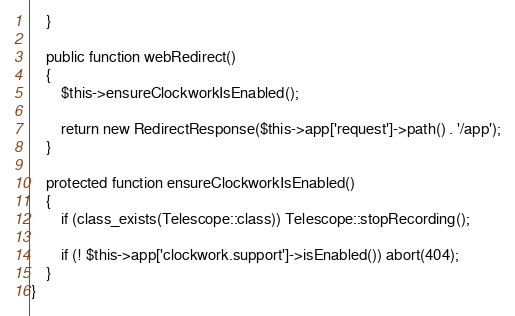<code> <loc_0><loc_0><loc_500><loc_500><_PHP_>	}

	public function webRedirect()
	{
		$this->ensureClockworkIsEnabled();

		return new RedirectResponse($this->app['request']->path() . '/app');
	}

	protected function ensureClockworkIsEnabled()
	{
		if (class_exists(Telescope::class)) Telescope::stopRecording();

		if (! $this->app['clockwork.support']->isEnabled()) abort(404);
	}
}
</code> 